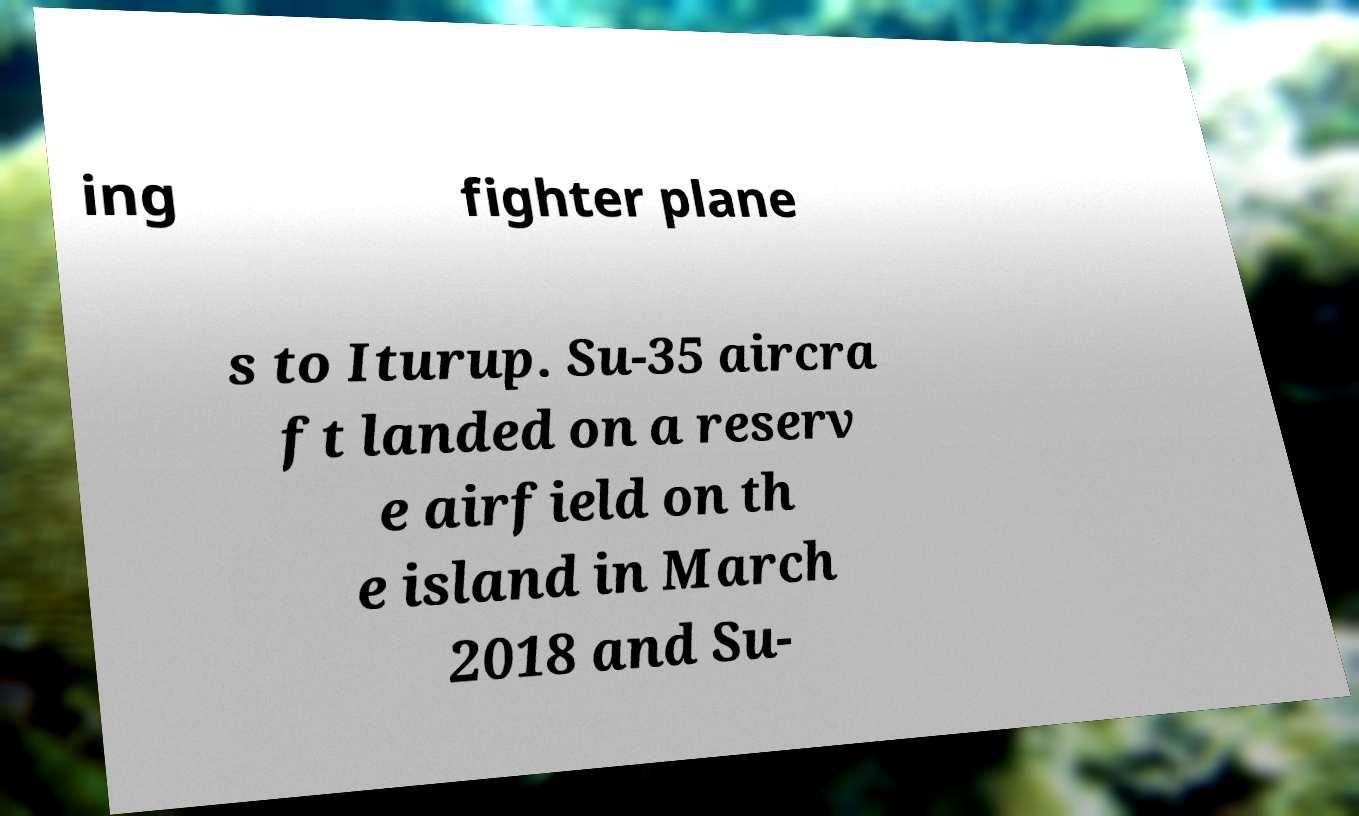Could you extract and type out the text from this image? ing fighter plane s to Iturup. Su-35 aircra ft landed on a reserv e airfield on th e island in March 2018 and Su- 